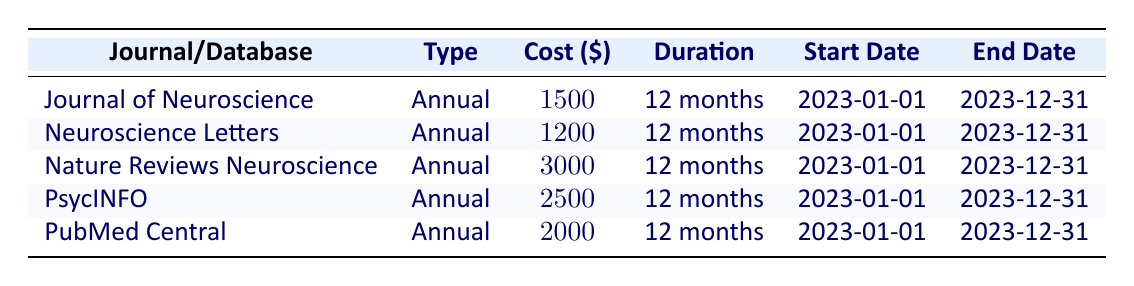What is the total cost of all subscriptions listed in the table? To find the total cost of all subscriptions, we add the individual costs: 1500 (Journal of Neuroscience) + 1200 (Neuroscience Letters) + 3000 (Nature Reviews Neuroscience) + 2500 (PsycINFO) + 2000 (PubMed Central) = 10200.
Answer: 10200 Which journal has the highest subscription cost? Looking through the costs listed in the table, Nature Reviews Neuroscience has the highest cost of 3000 compared to the other subscriptions listed.
Answer: Nature Reviews Neuroscience Is the subscription cost for Neuroscience Letters less than 1500? The cost of Neuroscience Letters is 1200, which is indeed less than 1500. Therefore, the statement is true.
Answer: Yes On what date does the Journal of Neuroscience subscription end? The end date for the Journal of Neuroscience subscription is clearly listed in the table as 2023-12-31.
Answer: 2023-12-31 What is the average subscription cost across all the journals and databases? First, we sum all the costs: 1500 + 1200 + 3000 + 2500 + 2000 = 10200. Then we divide by the number of subscriptions (5): 10200 / 5 = 2040.
Answer: 2040 Is PsycINFO more expensive than PubMed Central? The cost of PsycINFO is 2500, while the cost for PubMed Central is 2000. Since 2500 is greater than 2000, the statement is true.
Answer: Yes What is the duration of the subscription for the Journal of Neuroscience? The duration for the Journal of Neuroscience is specified in the table as 12 months.
Answer: 12 months If I wanted to cancel all subscriptions after 6 months, what would be the total cost incurred for the first half of the subscriptions? Each subscription costs are based on annual durations, so we take half of their costs: Journal of Neuroscience (750) + Neuroscience Letters (600) + Nature Reviews Neuroscience (1500) + PsycINFO (1250) + PubMed Central (1000) = 4100.
Answer: 4100 